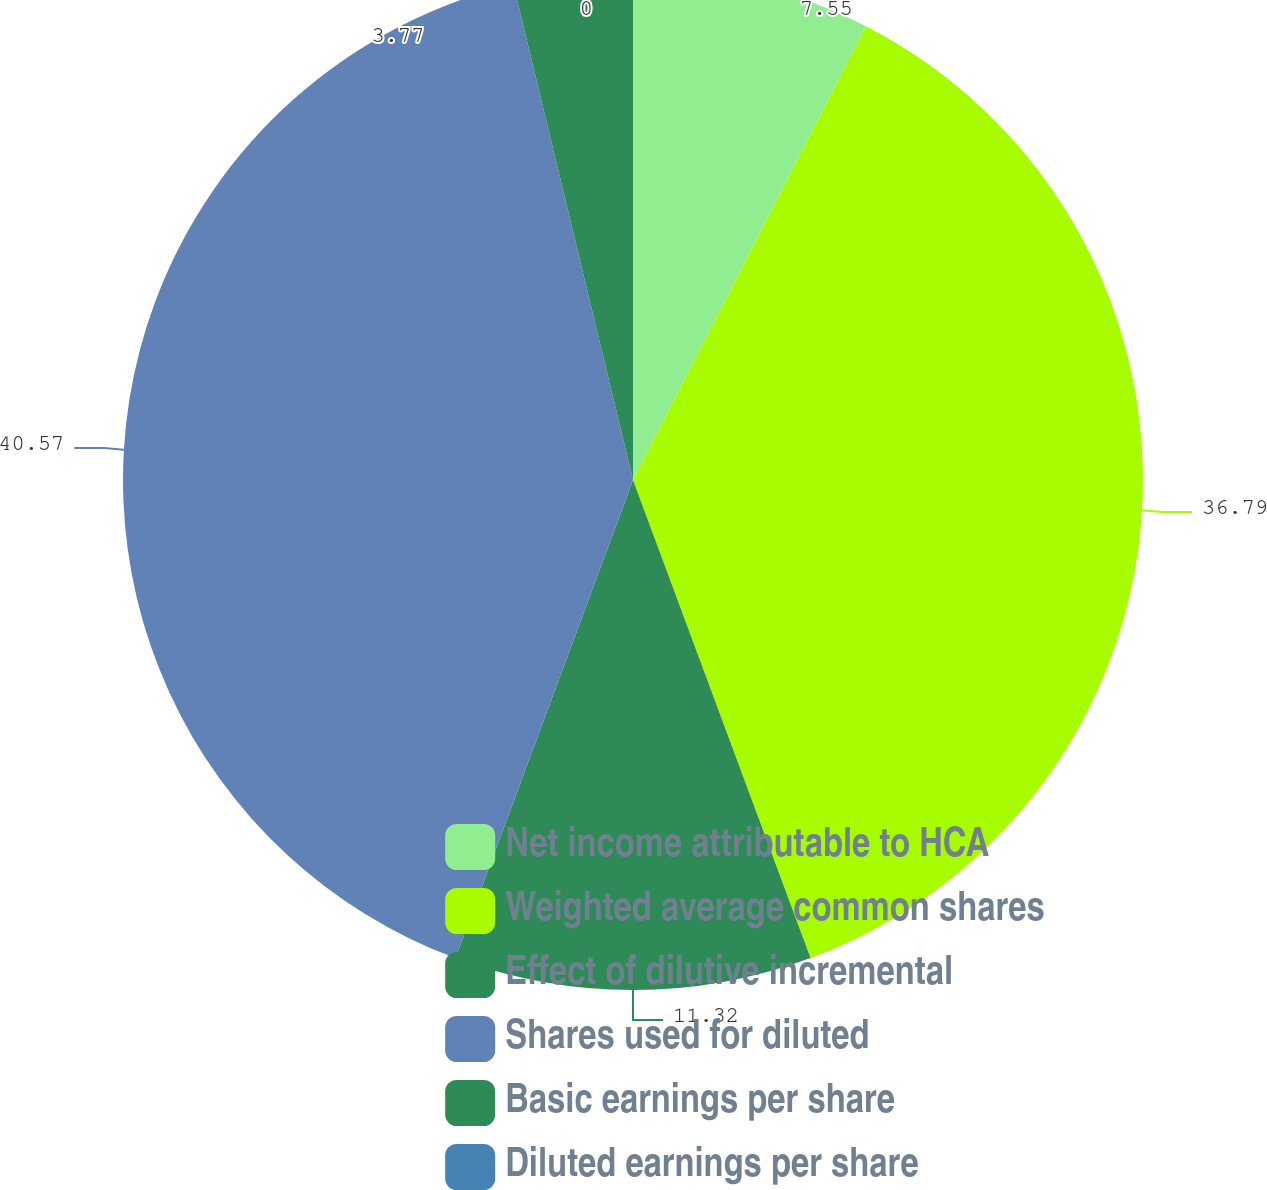Convert chart to OTSL. <chart><loc_0><loc_0><loc_500><loc_500><pie_chart><fcel>Net income attributable to HCA<fcel>Weighted average common shares<fcel>Effect of dilutive incremental<fcel>Shares used for diluted<fcel>Basic earnings per share<fcel>Diluted earnings per share<nl><fcel>7.55%<fcel>36.79%<fcel>11.32%<fcel>40.57%<fcel>3.77%<fcel>0.0%<nl></chart> 